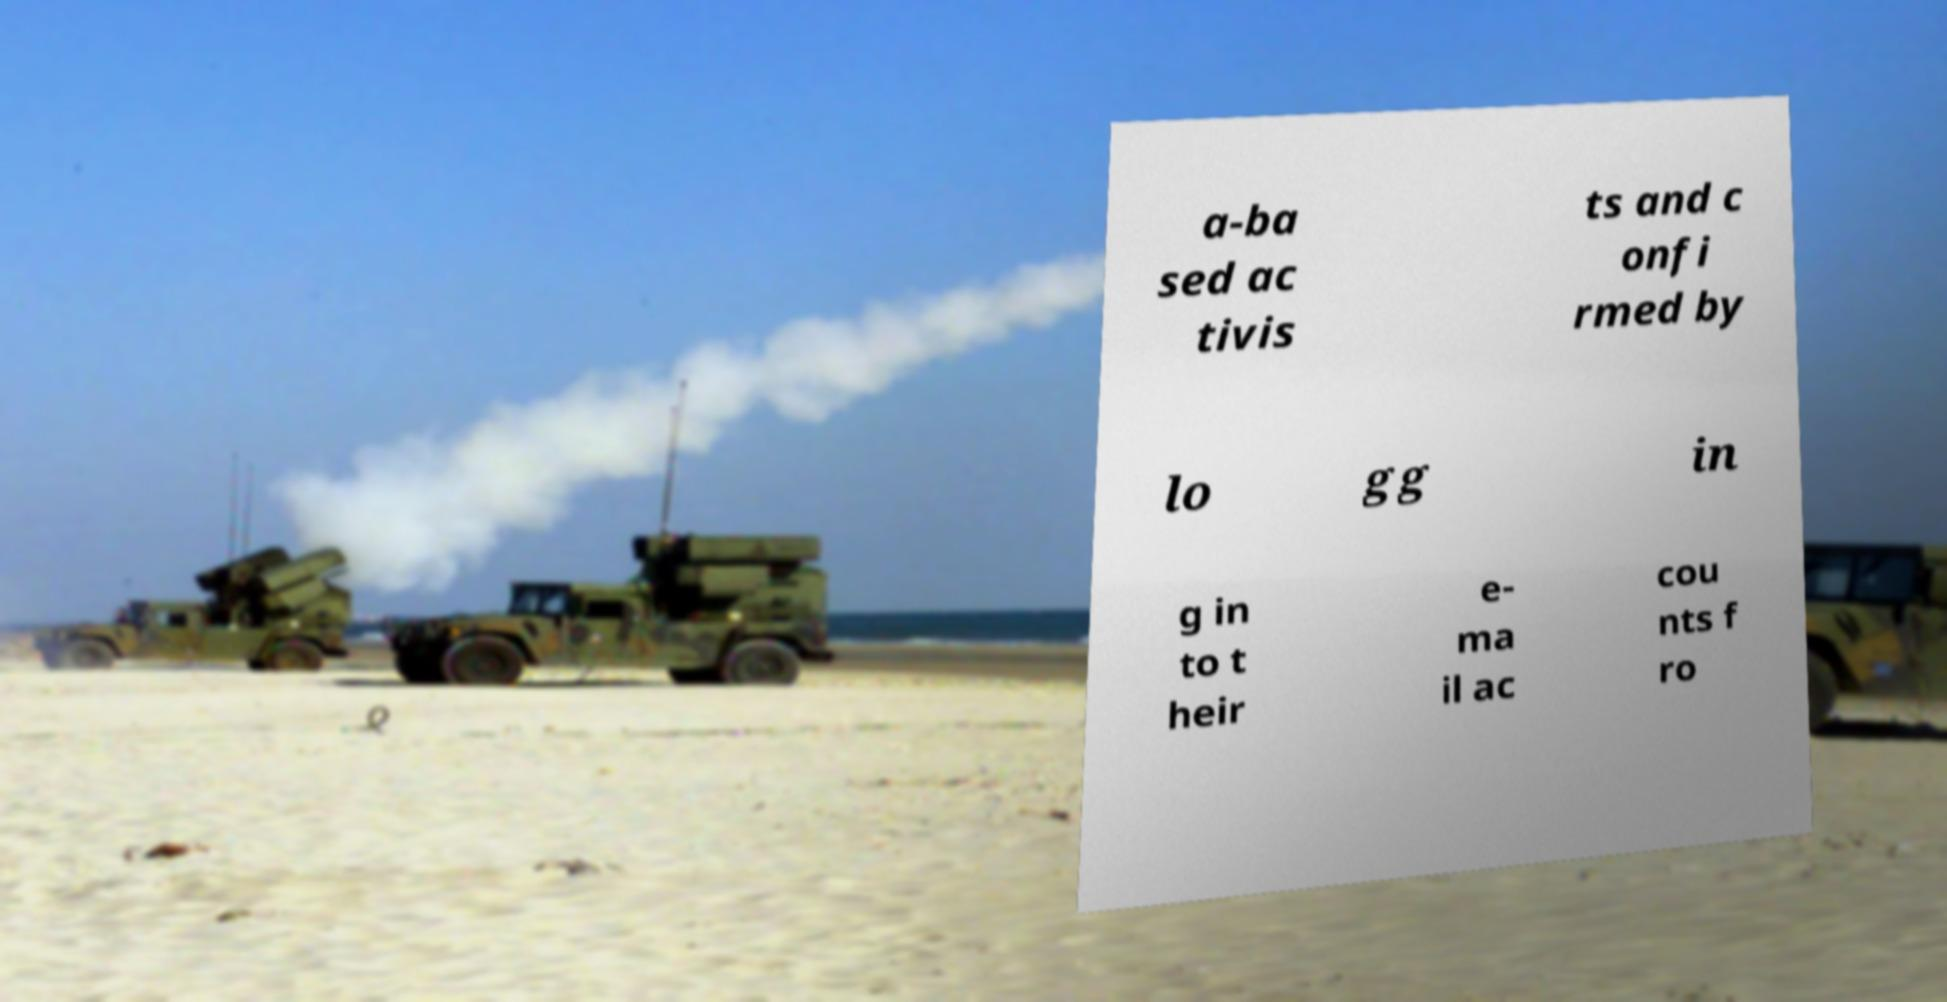For documentation purposes, I need the text within this image transcribed. Could you provide that? a-ba sed ac tivis ts and c onfi rmed by lo gg in g in to t heir e- ma il ac cou nts f ro 